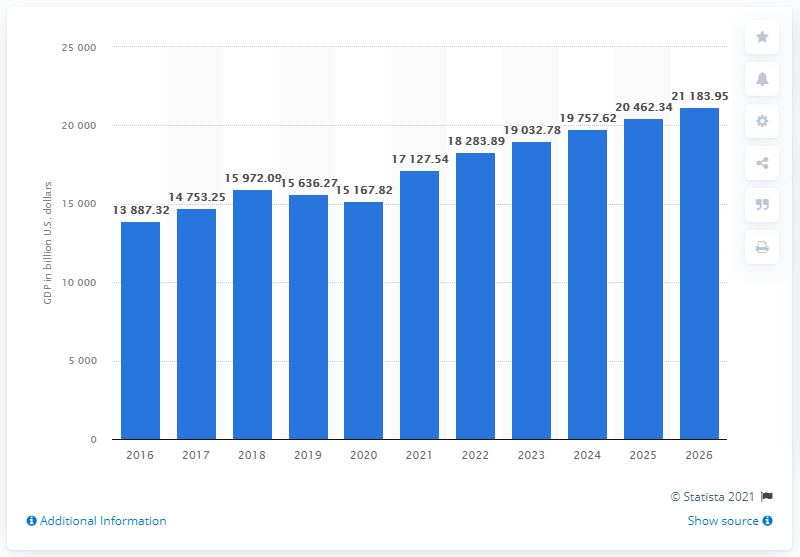Draw attention to some important aspects in this diagram. The Gross Domestic Product (GDP) of the European Union (EU) was 15,167.82 billion dollars in 2020. 